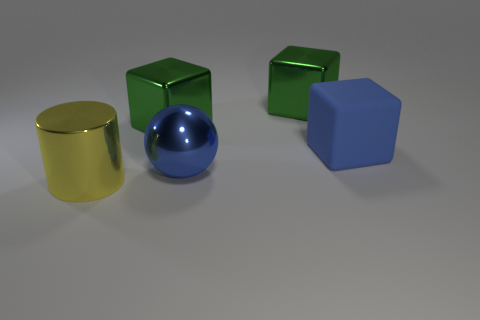What number of big things have the same color as the matte block?
Ensure brevity in your answer.  1. There is a ball; is it the same color as the big matte thing that is on the right side of the blue sphere?
Keep it short and to the point. Yes. Does the matte thing that is behind the big blue metallic object have the same color as the ball?
Your answer should be compact. Yes. Are there any other things that are the same color as the big cylinder?
Provide a succinct answer. No. What is the shape of the blue thing that is the same material as the cylinder?
Your answer should be compact. Sphere. Is the color of the ball the same as the big rubber thing?
Your response must be concise. Yes. What is the shape of the metallic thing that is the same color as the rubber cube?
Offer a terse response. Sphere. How many other blue matte objects have the same shape as the big rubber object?
Your answer should be very brief. 0. Is the blue cube the same size as the blue ball?
Your response must be concise. Yes. Is there a large shiny thing?
Your answer should be very brief. Yes. 